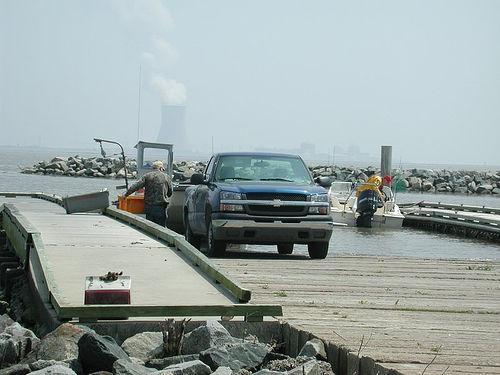What is the red and white box on the left used for?

Choices:
A) shipping
B) keeping cool
C) solving puzzles
D) collecting sand keeping cool 